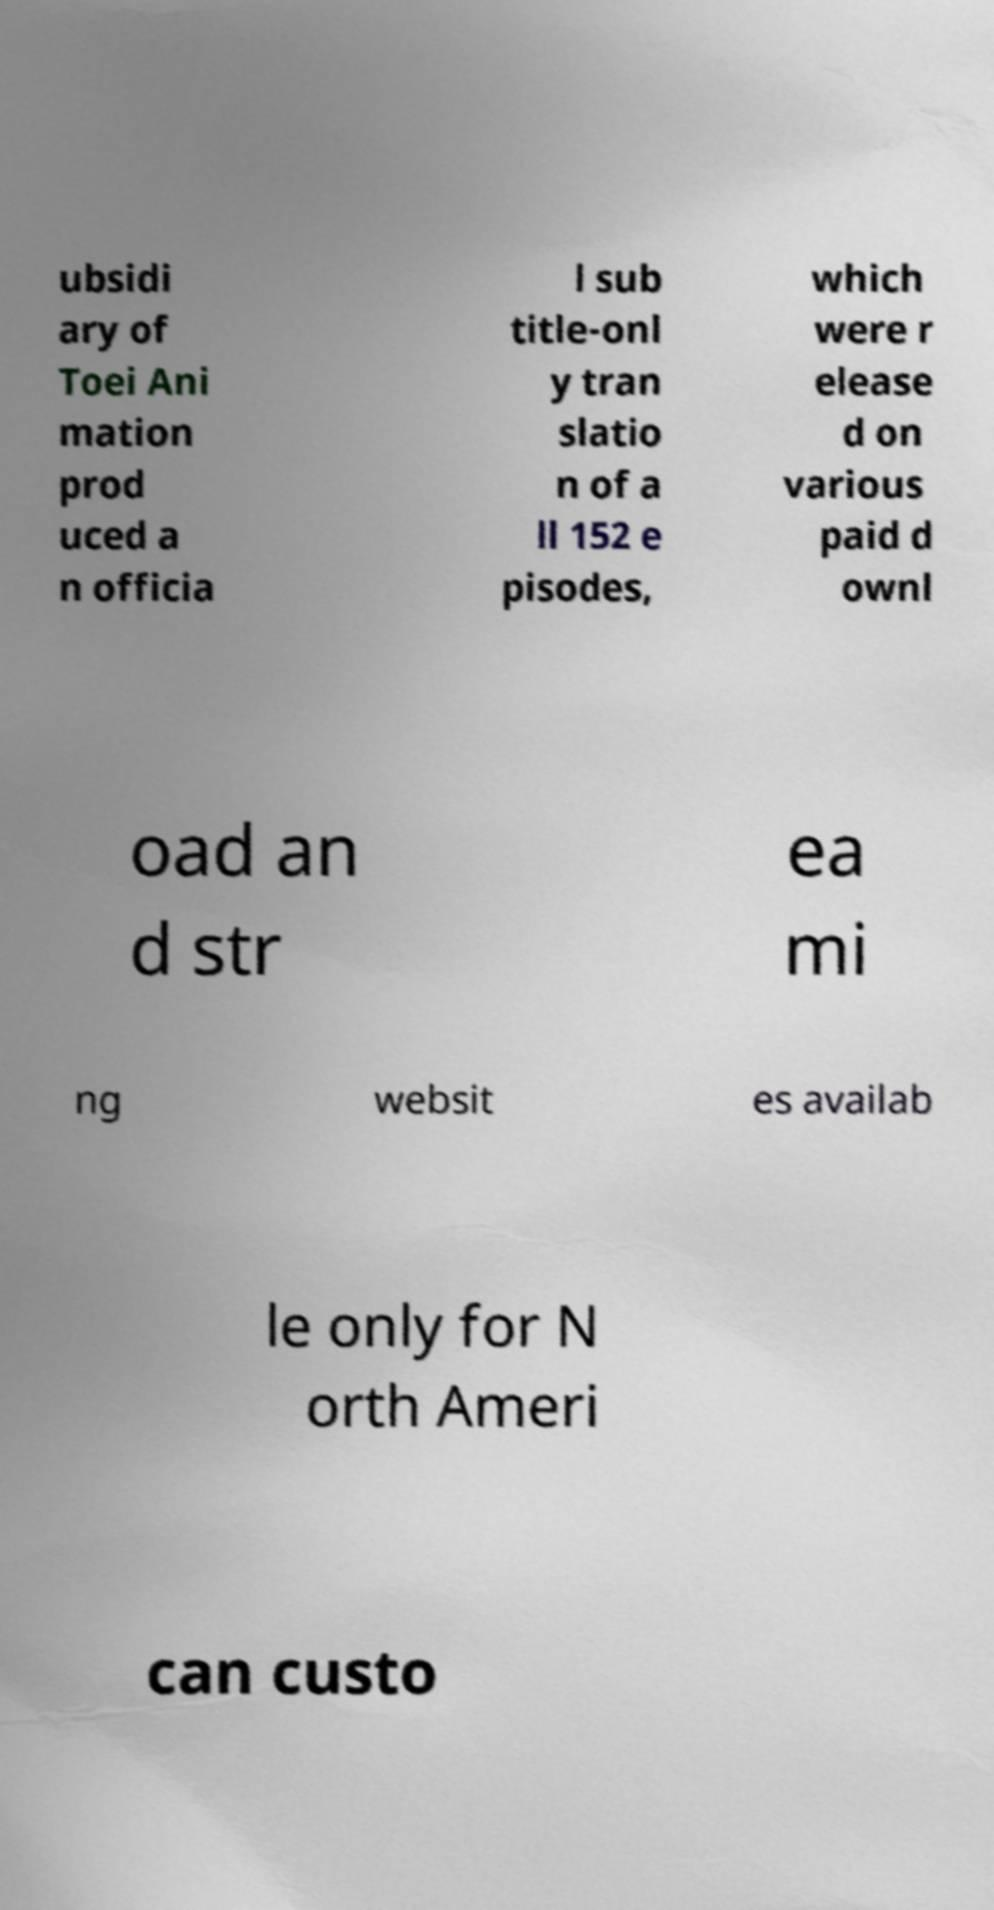For documentation purposes, I need the text within this image transcribed. Could you provide that? ubsidi ary of Toei Ani mation prod uced a n officia l sub title-onl y tran slatio n of a ll 152 e pisodes, which were r elease d on various paid d ownl oad an d str ea mi ng websit es availab le only for N orth Ameri can custo 